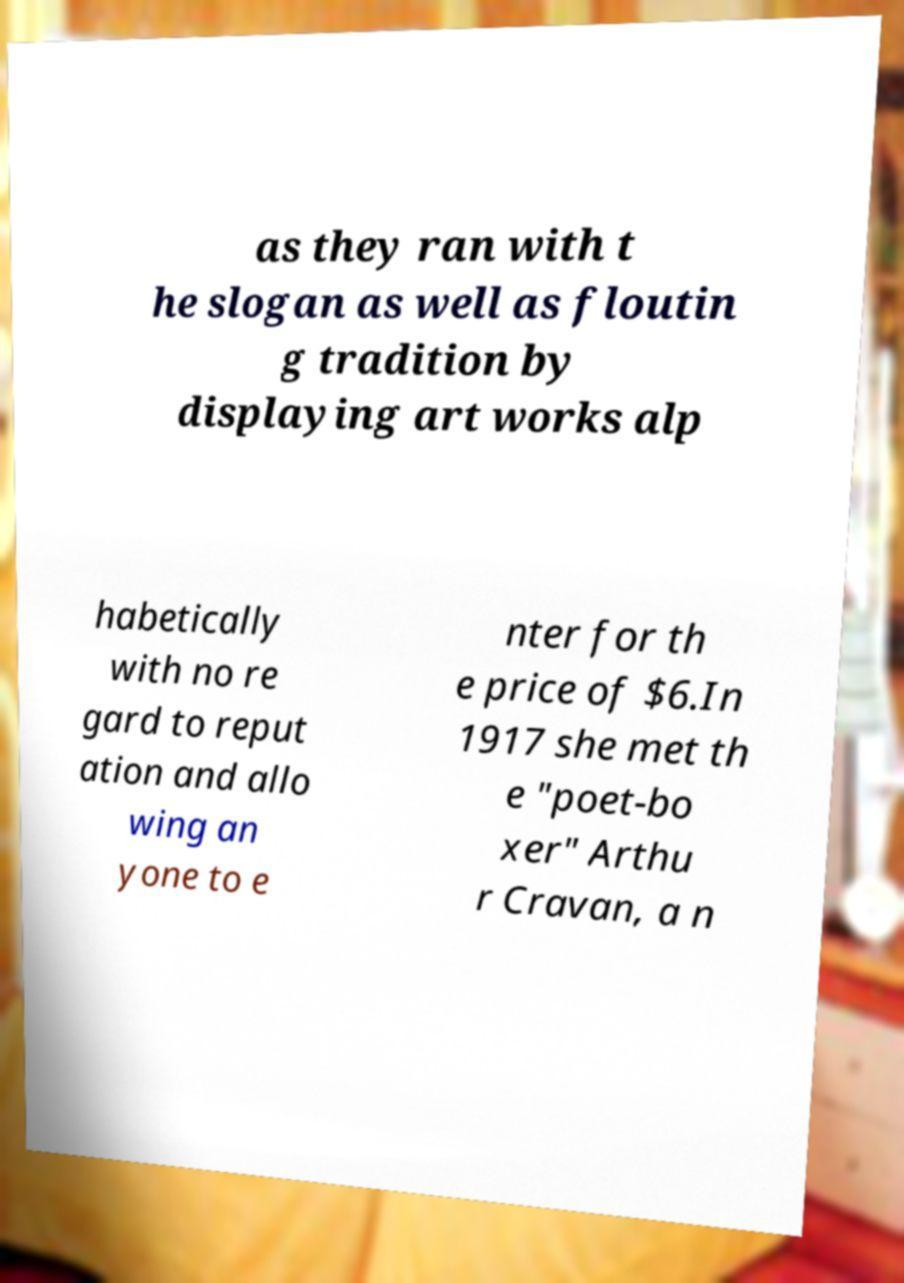I need the written content from this picture converted into text. Can you do that? as they ran with t he slogan as well as floutin g tradition by displaying art works alp habetically with no re gard to reput ation and allo wing an yone to e nter for th e price of $6.In 1917 she met th e "poet-bo xer" Arthu r Cravan, a n 